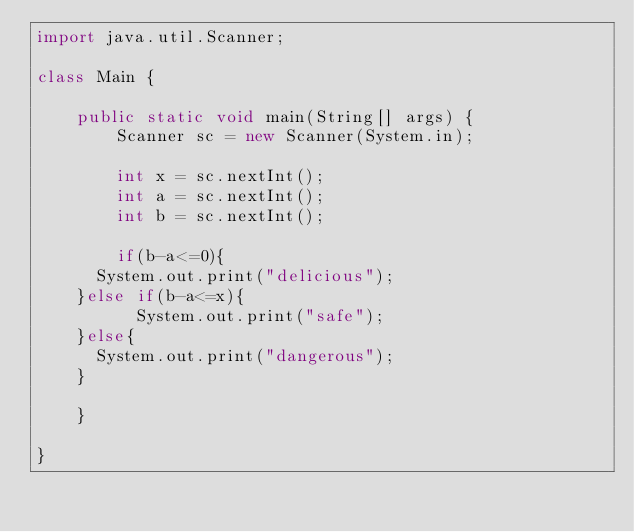<code> <loc_0><loc_0><loc_500><loc_500><_Java_>import java.util.Scanner;

class Main {

	public static void main(String[] args) {
		Scanner sc = new Scanner(System.in);

		int x = sc.nextInt();
		int a = sc.nextInt();
		int b = sc.nextInt();

		if(b-a<=0){
      System.out.print("delicious");
    }else if(b-a<=x){
		  System.out.print("safe");
    }else{
      System.out.print("dangerous");
    }

	}

}
</code> 